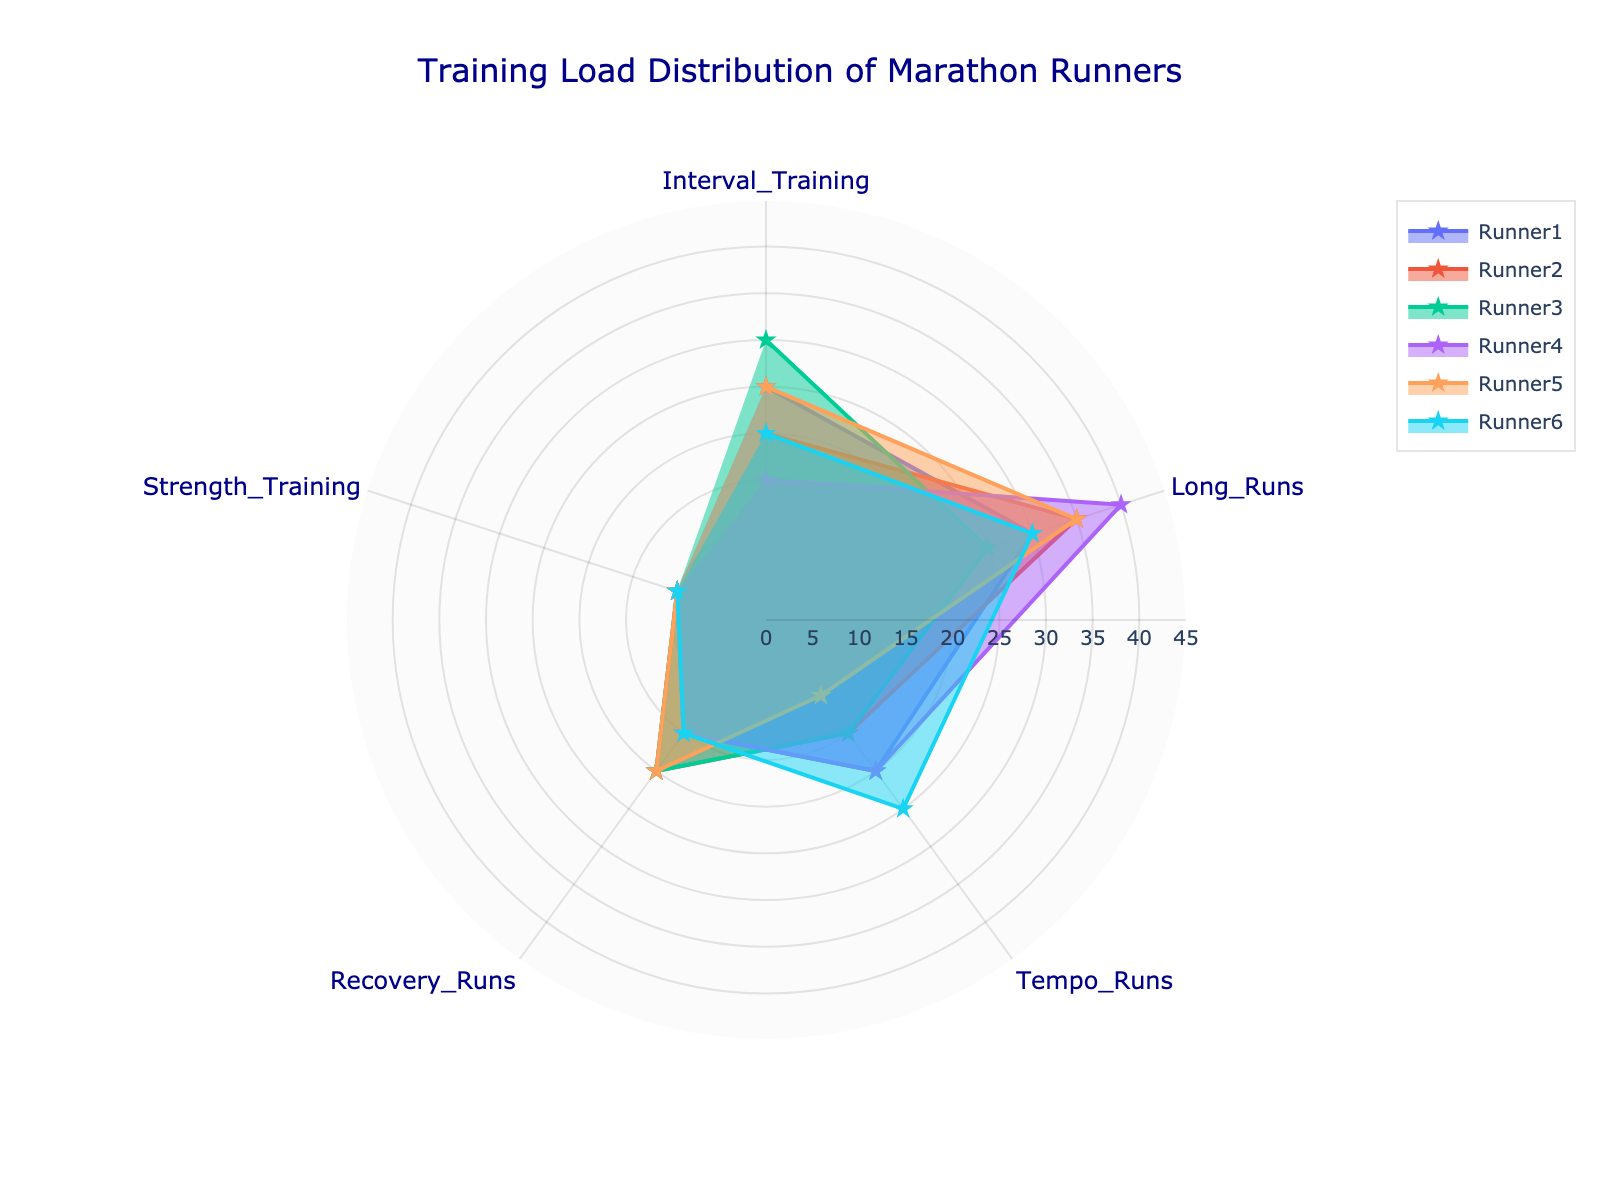What's the title of the chart? The title is prominently displayed at the top of the figure, providing context for the viewer. It reads 'Training Load Distribution of Marathon Runners'.
Answer: Training Load Distribution of Marathon Runners Which training type does Runner4 dedicate the most time to? By examining Runner4's radar plot, it shows a significantly higher value in the 'Long Runs' category compared to the other training types.
Answer: Long Runs What’s the average load of Interval Training for all runners? Adding the interval training values (25+20+30+15+25+20) results in 135. Dividing by the 6 runners gives 135/6.
Answer: 22.5 Which runners allocate the same amount of training load to Strength Training? Observing the radar chart, the Strength Training loads for all runners are the same, indicated by uniform values.
Answer: All runners Who has the highest load in Tempo Runs and what is the value? From the radar chart, Runner6 has the largest segment in the Tempo Runs category with a value of 25.
Answer: Runner6, 25 How does Runner1’s load in Recovery Runs compare to Runner5’s load in the same category? Both Runner1 and Runner5 have the same segment length for Recovery Runs, showing equal values.
Answer: Same What's the difference between the highest and lowest Long Runs value? The highest Long Runs value is 40 and the lowest is 25. The difference is 40 - 25.
Answer: 15 If you average the Long Runs load for Runner2 and Runner5, what do you get? Adding the Long Runs values for Runner2 and Runner5 (35 + 35) and dividing by 2 results in (35 + 35) / 2.
Answer: 35 Which runner has the most evenly distributed training load across all training types? Reviewing the chart, a more balanced distribution is seen for Runner6, where the segments appear close in size across categories.
Answer: Runner6 